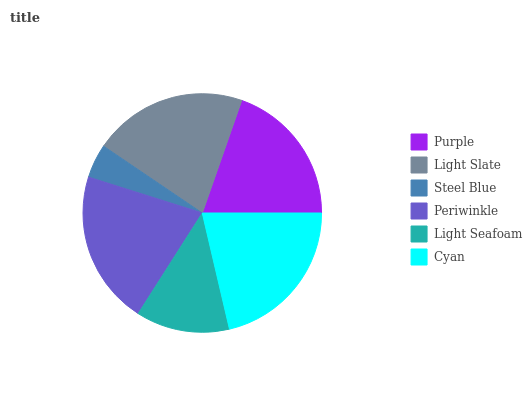Is Steel Blue the minimum?
Answer yes or no. Yes. Is Cyan the maximum?
Answer yes or no. Yes. Is Light Slate the minimum?
Answer yes or no. No. Is Light Slate the maximum?
Answer yes or no. No. Is Light Slate greater than Purple?
Answer yes or no. Yes. Is Purple less than Light Slate?
Answer yes or no. Yes. Is Purple greater than Light Slate?
Answer yes or no. No. Is Light Slate less than Purple?
Answer yes or no. No. Is Periwinkle the high median?
Answer yes or no. Yes. Is Purple the low median?
Answer yes or no. Yes. Is Steel Blue the high median?
Answer yes or no. No. Is Light Seafoam the low median?
Answer yes or no. No. 